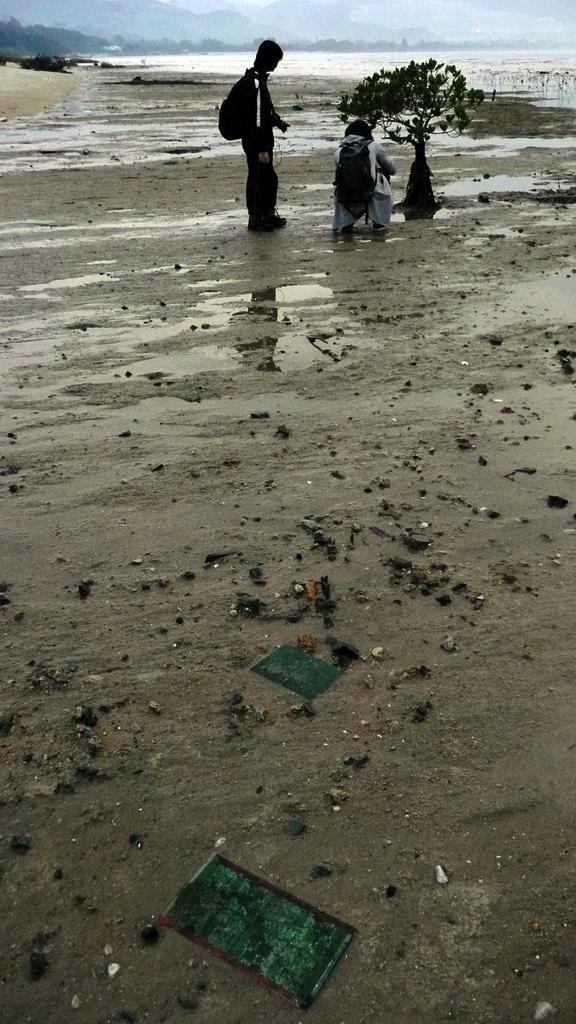How many people are in the image? There are two people in the image. What are the people wearing on their backs? The people are wearing backpacks. What is the terrain like in the image? The people are standing on muddy water. What type of vegetation can be seen in the image? There is a plant visible in the image. What natural element is present in the image? There is water visible in the image. What can be seen in the distance in the image? There are hills in the background of the image. How many hydrants are visible in the image? There are no hydrants present in the image. What type of eggs can be seen in the image? There are no eggs present in the image. 